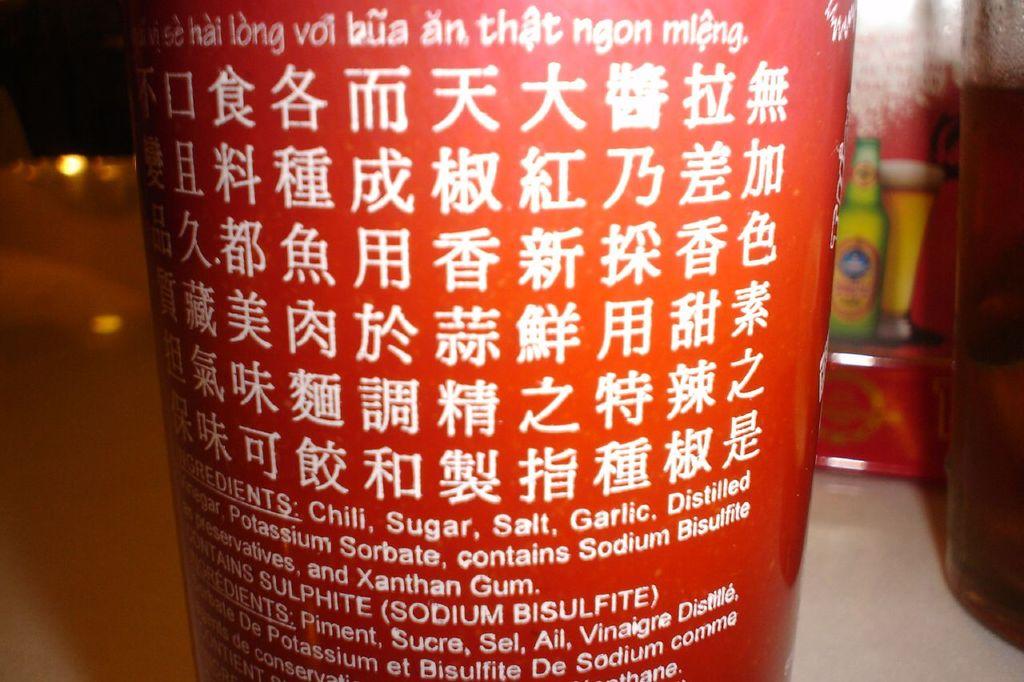What are the ingredients?
Ensure brevity in your answer.  Chili, sugar, salt, garlic. How many languages are the ingredients in?
Make the answer very short. 2. 